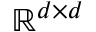Convert formula to latex. <formula><loc_0><loc_0><loc_500><loc_500>\mathbb { R } ^ { d \times d }</formula> 